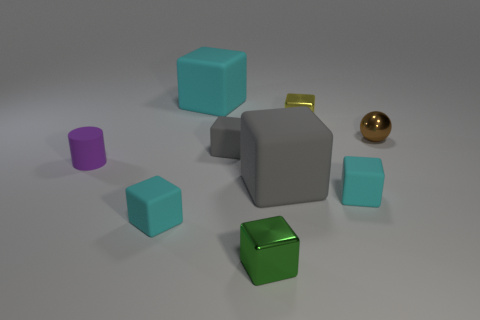Subtract all green balls. How many cyan cubes are left? 3 Subtract all gray blocks. How many blocks are left? 5 Subtract all gray rubber blocks. How many blocks are left? 5 Subtract all green blocks. Subtract all gray cylinders. How many blocks are left? 6 Add 1 green objects. How many objects exist? 10 Subtract all cylinders. How many objects are left? 8 Subtract all big cyan matte things. Subtract all small brown things. How many objects are left? 7 Add 6 gray rubber things. How many gray rubber things are left? 8 Add 5 tiny gray objects. How many tiny gray objects exist? 6 Subtract 1 gray blocks. How many objects are left? 8 